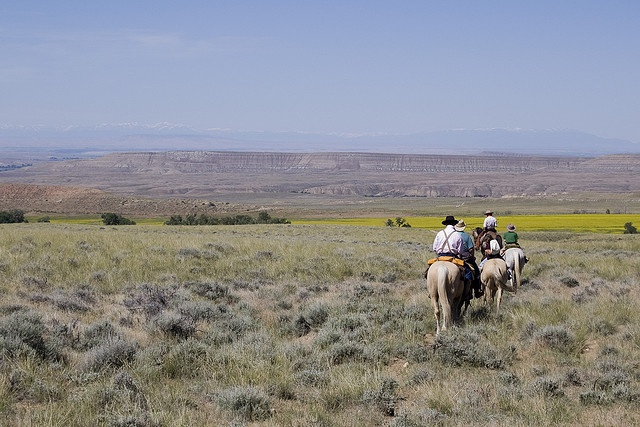Describe the objects in this image and their specific colors. I can see horse in darkgray, black, gray, and tan tones, horse in darkgray, black, tan, and gray tones, people in darkgray, lavender, black, and purple tones, people in darkgray, black, and gray tones, and horse in darkgray, lightgray, black, and gray tones in this image. 